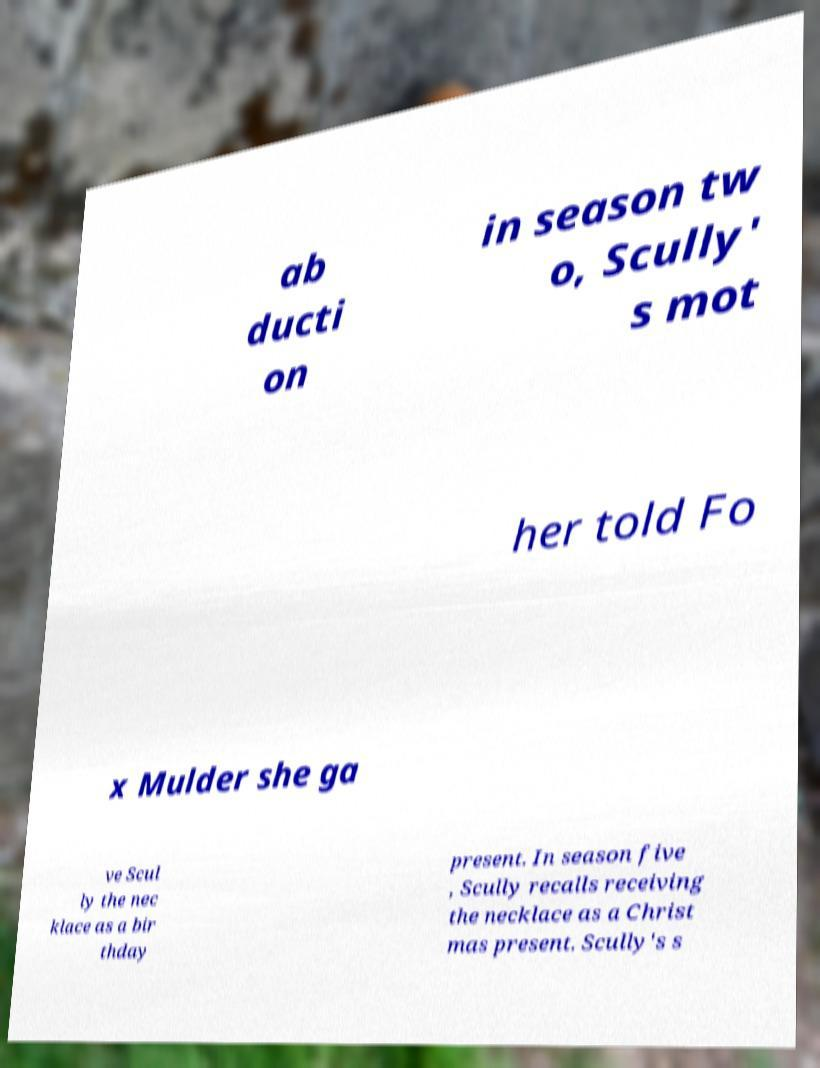Please read and relay the text visible in this image. What does it say? ab ducti on in season tw o, Scully' s mot her told Fo x Mulder she ga ve Scul ly the nec klace as a bir thday present. In season five , Scully recalls receiving the necklace as a Christ mas present. Scully's s 